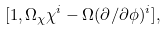<formula> <loc_0><loc_0><loc_500><loc_500>[ 1 , \Omega _ { \chi } \chi ^ { i } - \Omega ( \partial / \partial \phi ) ^ { i } ] ,</formula> 